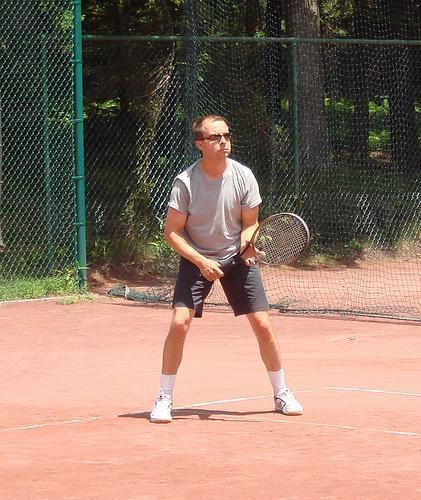How many people are in the picture?
Give a very brief answer. 1. How many tennis rackets can you count?
Give a very brief answer. 1. 